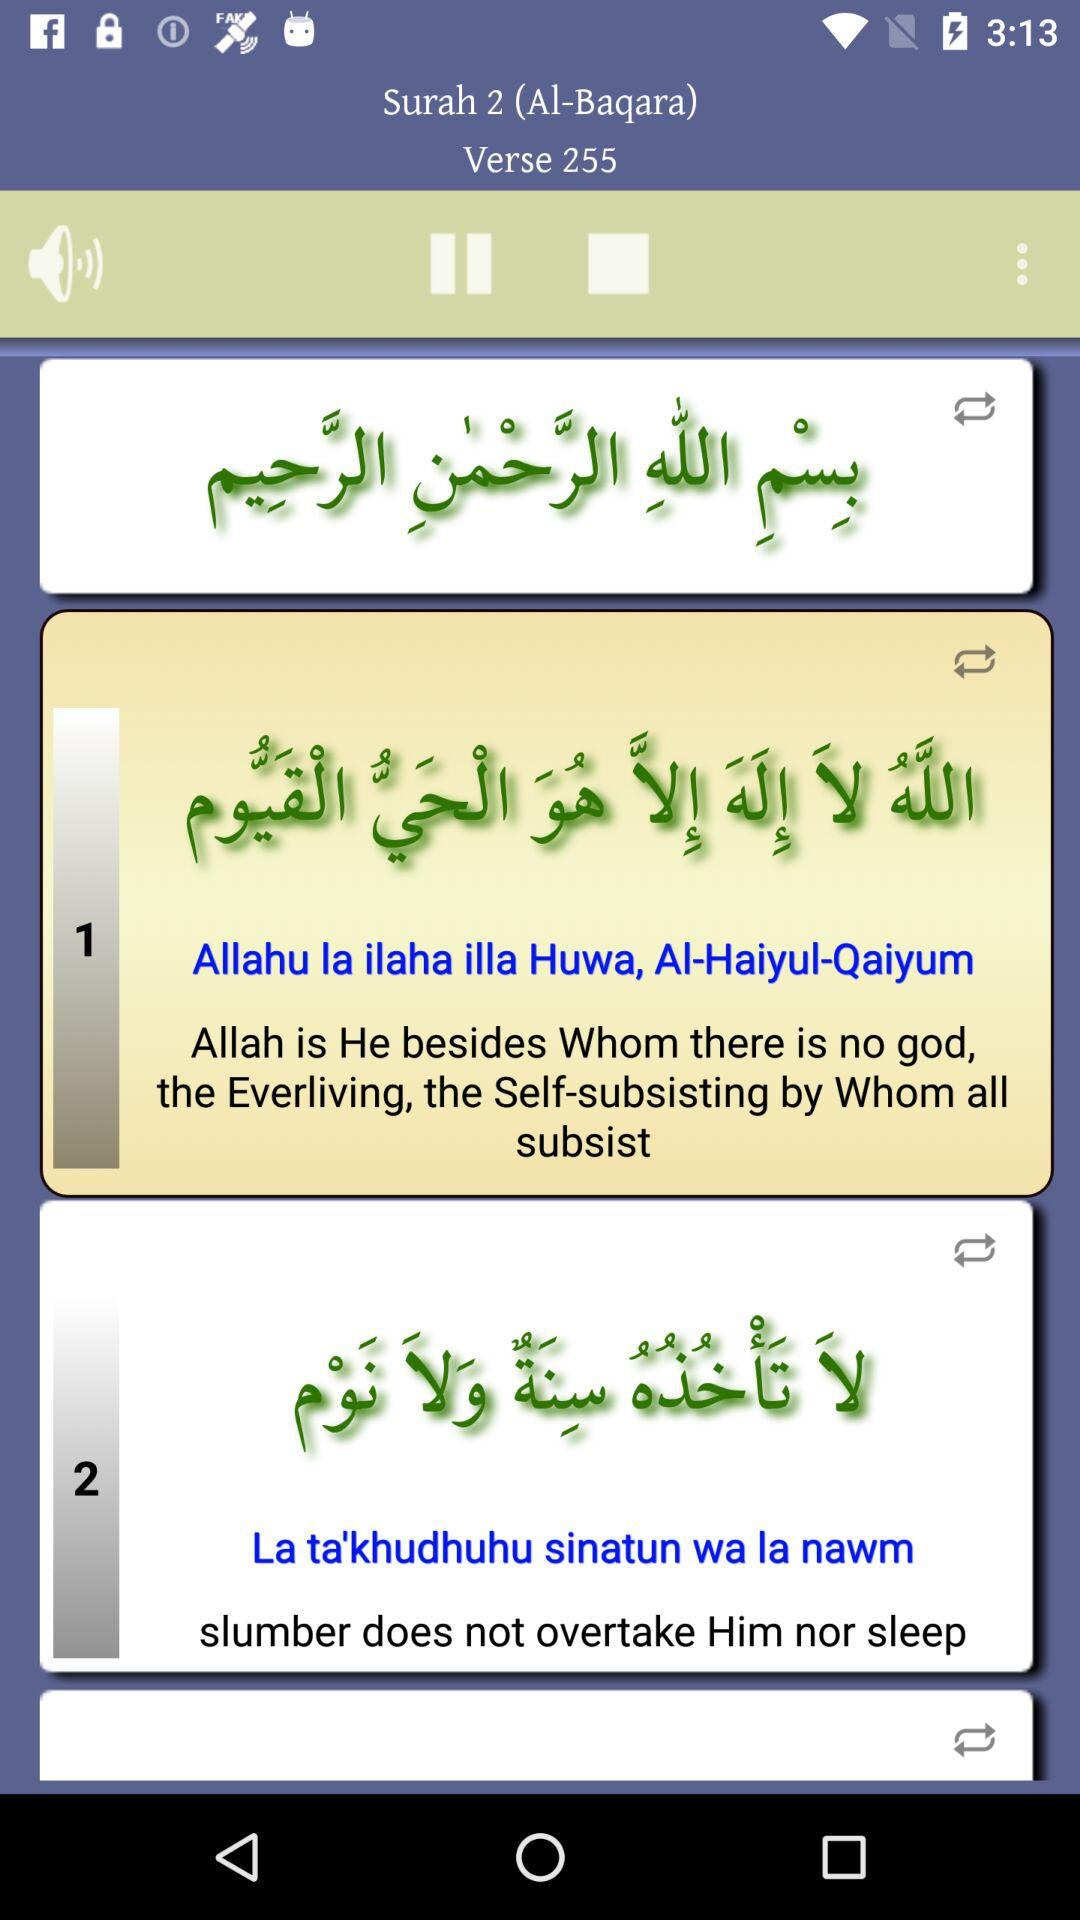What's the "Surah" number? The "Surah" number is 2. 